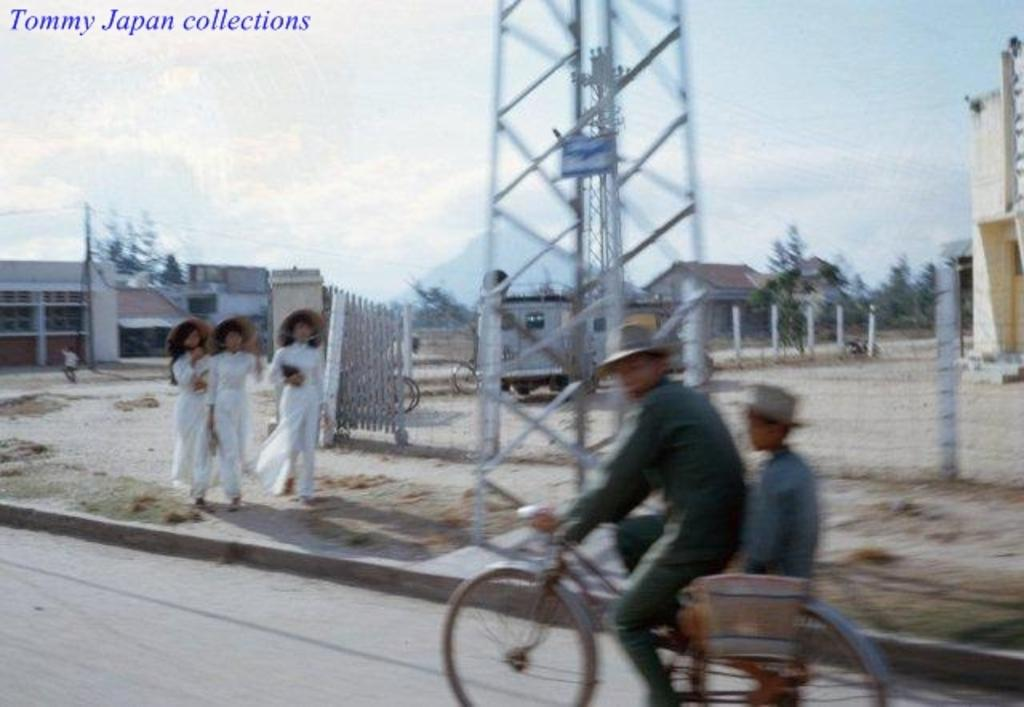What is the man in the image doing? The man is riding a bicycle in the image. What are the three people on the sidewalk doing? The three people are walking on the sidewalk in the image. What type of structures can be seen in the image? There are houses visible in the image. What type of vegetation is present in the image? There are trees present in the image. Who is the manager of the selection process in the image? There is no manager or selection process present in the image. What type of recess can be seen in the image? There is no recess present in the image. 